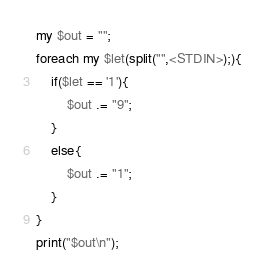<code> <loc_0><loc_0><loc_500><loc_500><_Perl_>
my $out = "";
foreach my $let(split("",<STDIN>);){
	if($let == '1'){
    	$out .= "9";
    }
    else{
		$out .= "1";
    }
}
print("$out\n");</code> 